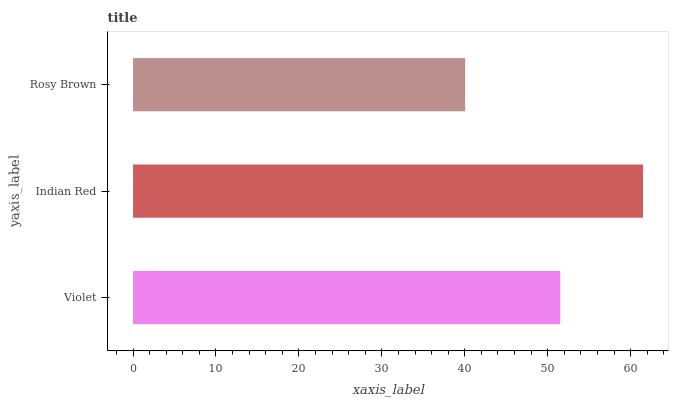Is Rosy Brown the minimum?
Answer yes or no. Yes. Is Indian Red the maximum?
Answer yes or no. Yes. Is Indian Red the minimum?
Answer yes or no. No. Is Rosy Brown the maximum?
Answer yes or no. No. Is Indian Red greater than Rosy Brown?
Answer yes or no. Yes. Is Rosy Brown less than Indian Red?
Answer yes or no. Yes. Is Rosy Brown greater than Indian Red?
Answer yes or no. No. Is Indian Red less than Rosy Brown?
Answer yes or no. No. Is Violet the high median?
Answer yes or no. Yes. Is Violet the low median?
Answer yes or no. Yes. Is Indian Red the high median?
Answer yes or no. No. Is Indian Red the low median?
Answer yes or no. No. 